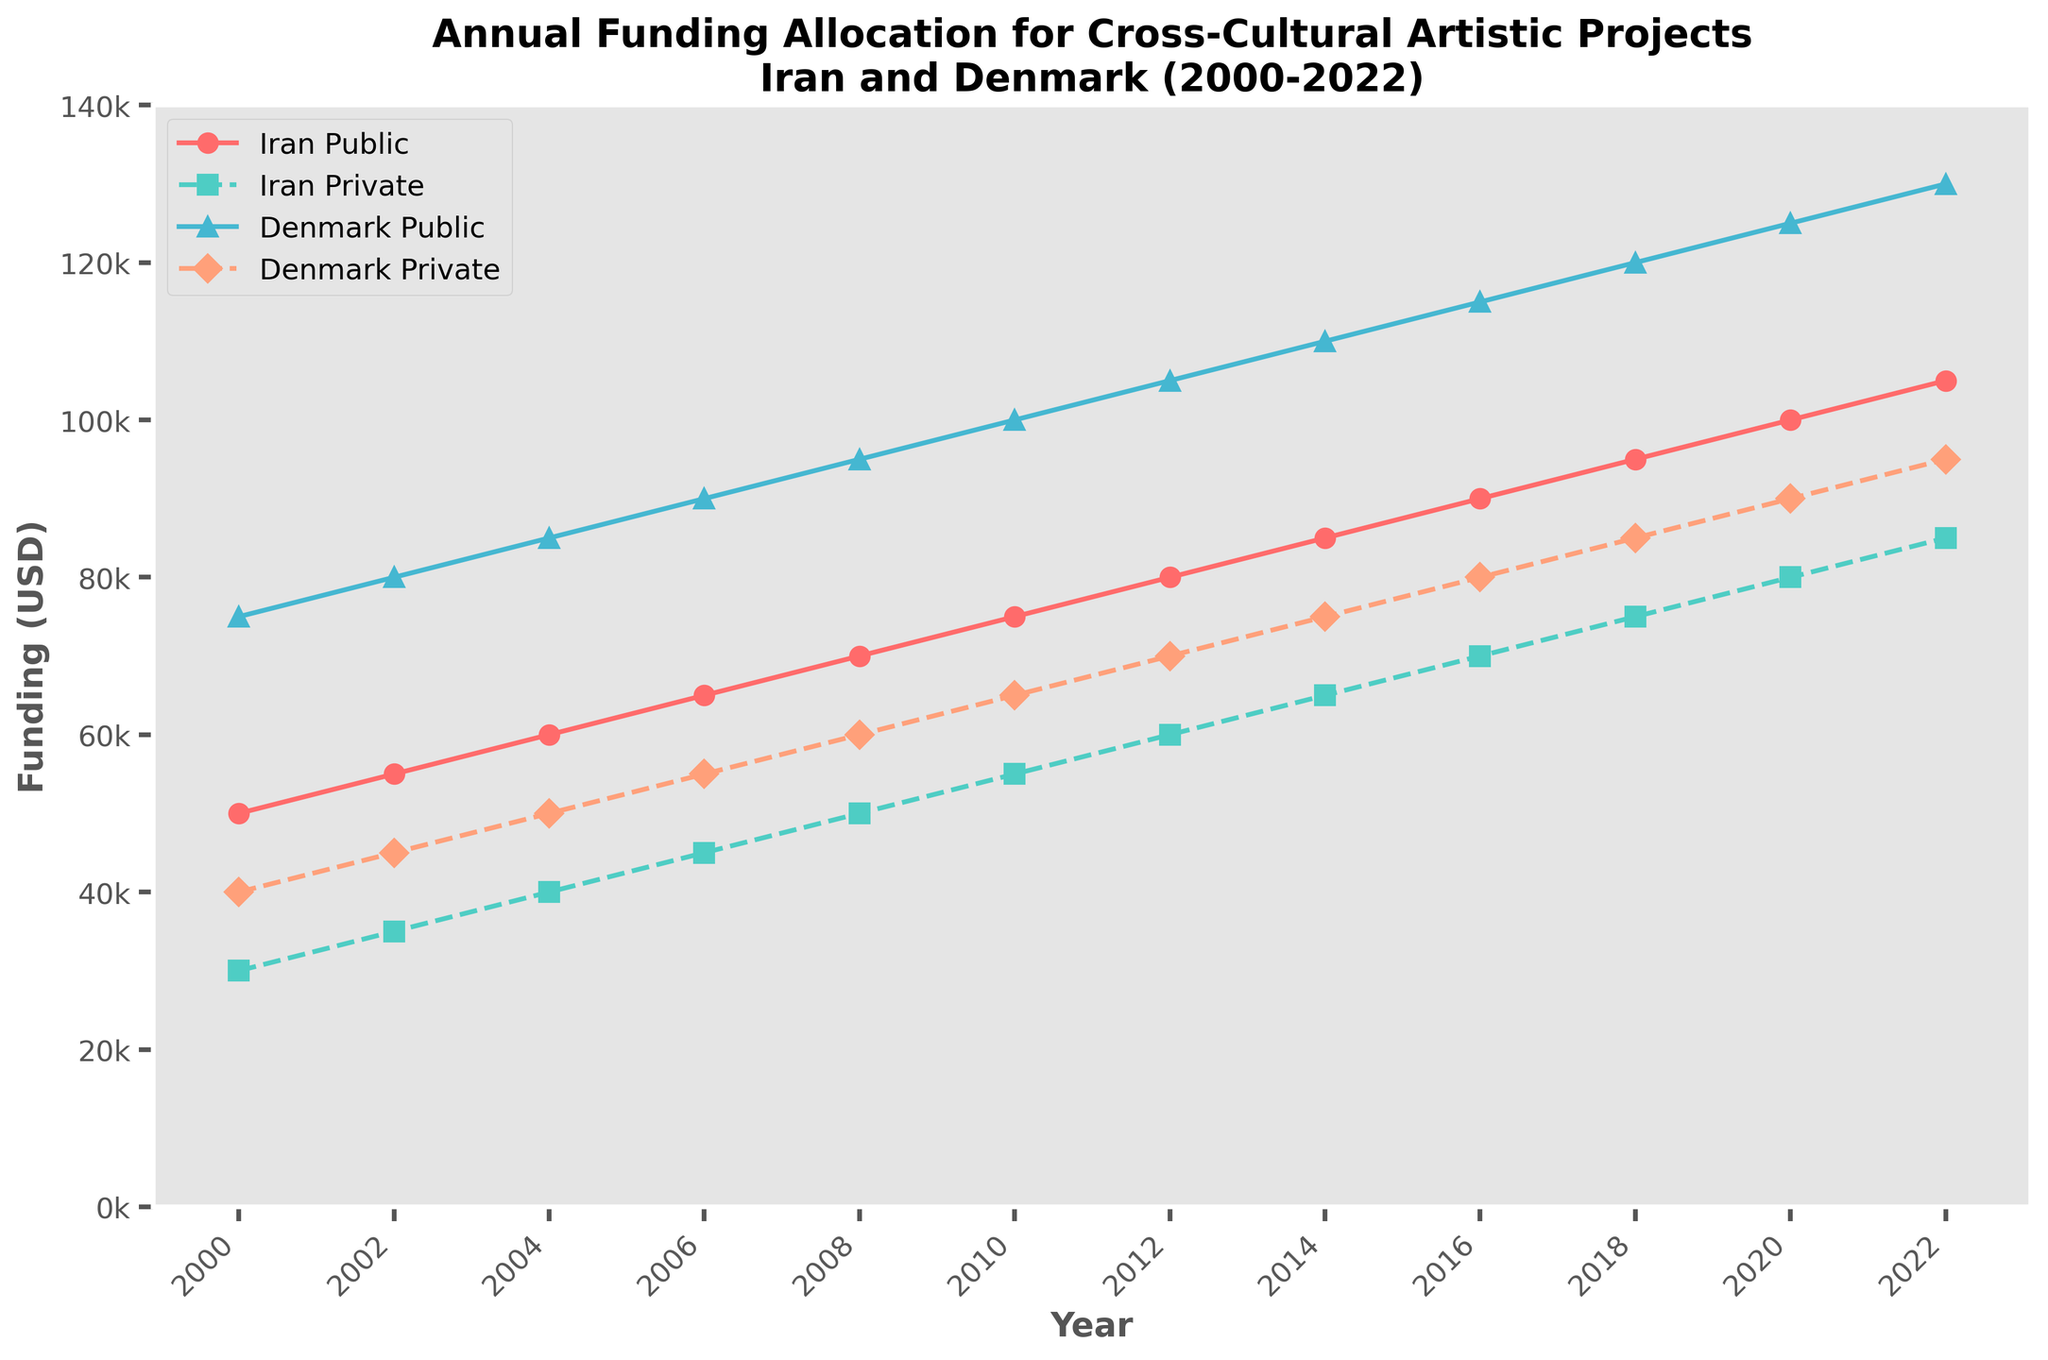What is the total funding allocation for Iran in 2022? The total funding for Iran in 2022 is the sum of the Iran Public and Iran Private allocations. For Iran Public, it is 105,000 USD and for Iran Private, it is 85,000 USD. Thus, the total is 105,000 + 85,000 = 190,000 USD
Answer: 190,000 USD Which funding source had the highest allocation in 2020? The possible sources are Iran Public, Iran Private, Denmark Public, and Denmark Private. For 2020, Iran Public is 100,000 USD, Iran Private is 80,000 USD, Denmark Public is 125,000 USD, and Denmark Private is 90,000 USD. Therefore, Denmark Public had the highest funding allocation in 2020.
Answer: Denmark Public How did the Denmark Public funding change from 2000 to 2022? In 2000, the Denmark Public funding was 75,000 USD; in 2022, it was 130,000 USD. The change is 130,000 - 75,000 = 55,000 USD increase
Answer: Increased by 55,000 USD What is the average private funding for Iran from 2000 to 2022? To find the average, sum all the Iran Private funding values from 2000 to 2022 and divide by the number of years (12). The total is 30000 + 35000 + 40000 + 45000 + 50000 + 55000 + 60000 + 65000 + 70000 + 75000 + 80000 + 85000 = 635000 USD. The average is 635000 / 12 = 52,917 USD (approximately)
Answer: 52,917 USD Which country had a higher total public funding allocation in 2016? In 2016, Iran Public funding is 90,000 USD and Denmark Public funding is 115,000 USD. Comparing these, Denmark’s public funding is higher.
Answer: Denmark By how much did Iran Private funding increase between 2000 and 2022? In 2000, Iran Private funding was 30,000 USD. In 2022, it was 85,000 USD. The increase is 85,000 - 30,000 = 55,000 USD.
Answer: 55,000 USD What trend can be observed for Denmark Private funding from 2002 to 2012? Denmark Private funding steadily increases over this period. In 2002 it is 45,000 USD, and by 2012 it reaches 70,000 USD, indicating a consistent upward trend.
Answer: Consistent upward trend How does the funding pattern for Iran Public compare to Iran Private over the years? Both Iran Public and Private funding show a steady increase over the years from 2000 to 2022. However, Iran Public funding is consistently higher than Iran Private each year.
Answer: Iran Public is consistently higher, both show steady increase Which type of funding (public or private) showed a sharper increase in allocation in Denmark from 2000 to 2022? Denmark Public funding increased from 75,000 USD in 2000 to 130,000 USD in 2022, an increase of 55,000 USD. Denmark Private funding increased from 40,000 USD in 2000 to 95,000 USD in 2022, an increase of 55,000 USD. Both public and private show the same increase.
Answer: Both increased equally In which year did Iran Public funding surpass 70,000 USD? Checking the Iran Public funding over the years, in 2008 it reaches 70,000 USD, and in 2010 it surpasses this figure to 75,000 USD. Therefore, 2010 is the year Iran Public funding surpasses 70,000 USD.
Answer: 2010 